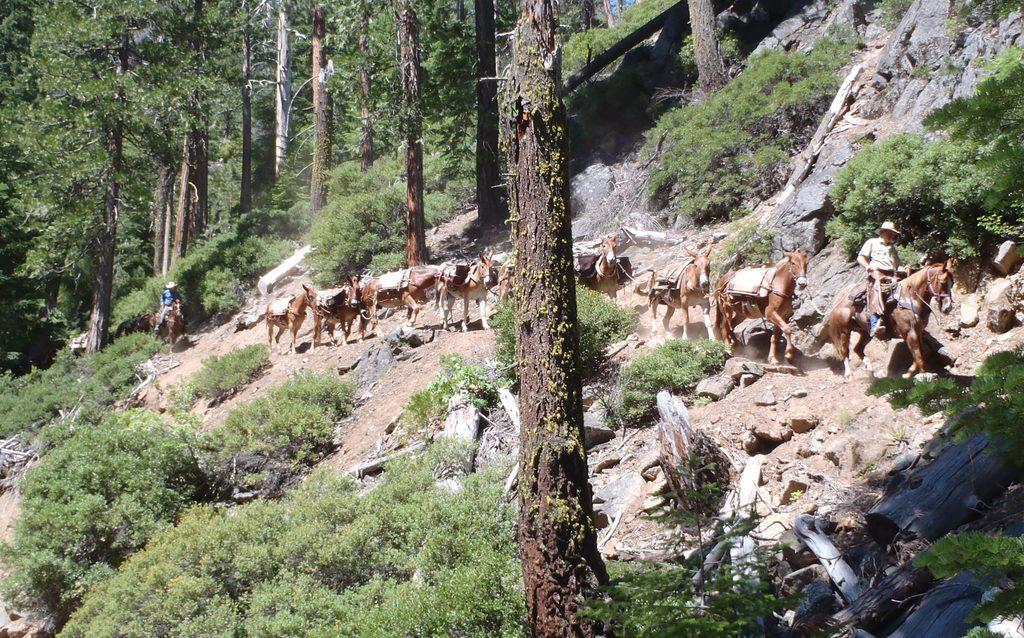Please provide a concise description of this image. In this image there are some horses are in middle of this image and right side of this image. There is one person is at left side of this image and one person is at right side of this image, and there are some trees in the background. There are some small plants are at bottom of this image. 